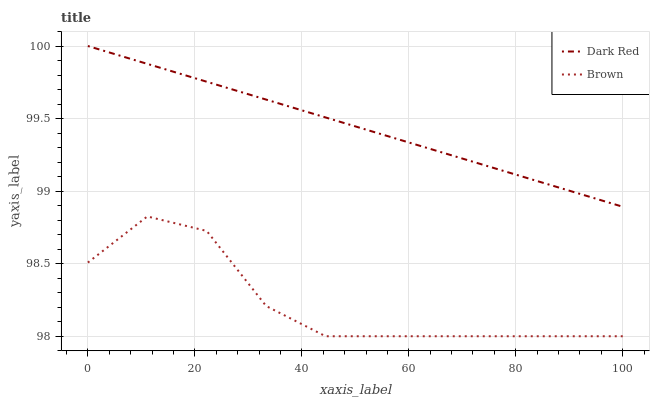Does Brown have the minimum area under the curve?
Answer yes or no. Yes. Does Dark Red have the maximum area under the curve?
Answer yes or no. Yes. Does Brown have the maximum area under the curve?
Answer yes or no. No. Is Dark Red the smoothest?
Answer yes or no. Yes. Is Brown the roughest?
Answer yes or no. Yes. Is Brown the smoothest?
Answer yes or no. No. Does Brown have the lowest value?
Answer yes or no. Yes. Does Dark Red have the highest value?
Answer yes or no. Yes. Does Brown have the highest value?
Answer yes or no. No. Is Brown less than Dark Red?
Answer yes or no. Yes. Is Dark Red greater than Brown?
Answer yes or no. Yes. Does Brown intersect Dark Red?
Answer yes or no. No. 